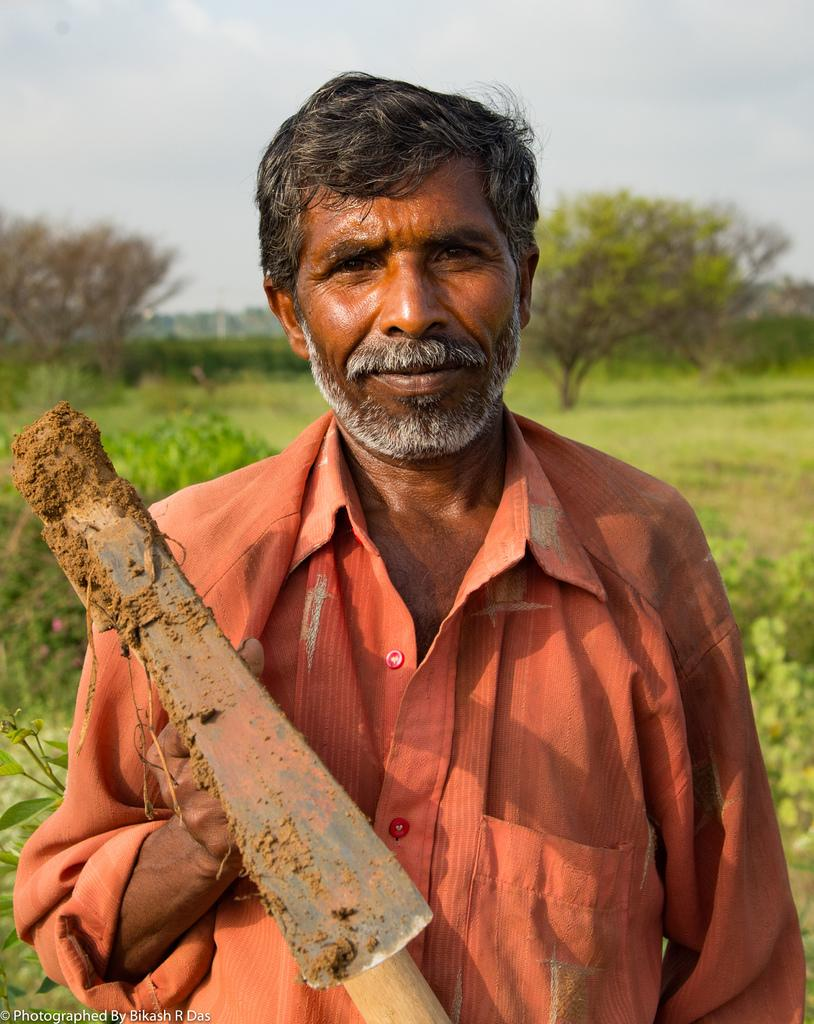What is the main subject of the image? The main subject of the image is a man. What is the man doing in the image? The man is standing and holding a pickaxe. What can be seen in the background of the image? There are trees, plants, grass, and the sky visible in the background of the image. What type of payment is the man receiving for his work in the image? There is no indication of payment in the image; it only shows a man standing and holding a pickaxe. Can you see any fairies flying around the man in the image? There are no fairies present in the image. 